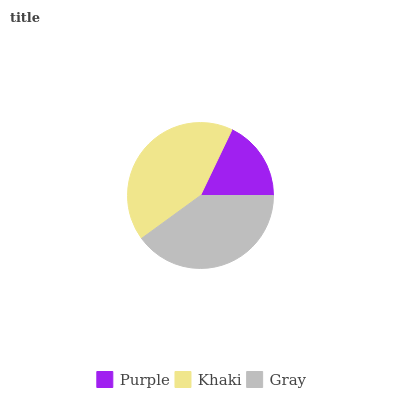Is Purple the minimum?
Answer yes or no. Yes. Is Khaki the maximum?
Answer yes or no. Yes. Is Gray the minimum?
Answer yes or no. No. Is Gray the maximum?
Answer yes or no. No. Is Khaki greater than Gray?
Answer yes or no. Yes. Is Gray less than Khaki?
Answer yes or no. Yes. Is Gray greater than Khaki?
Answer yes or no. No. Is Khaki less than Gray?
Answer yes or no. No. Is Gray the high median?
Answer yes or no. Yes. Is Gray the low median?
Answer yes or no. Yes. Is Khaki the high median?
Answer yes or no. No. Is Purple the low median?
Answer yes or no. No. 